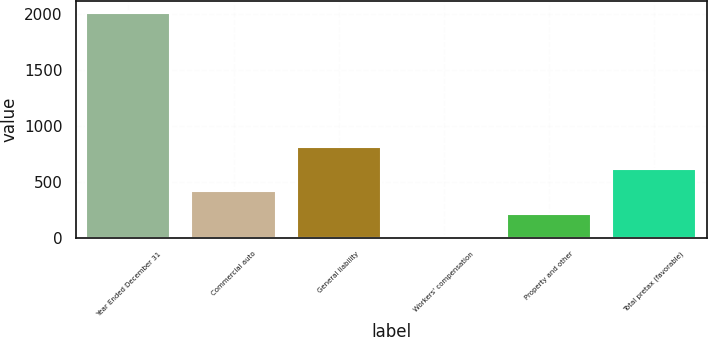Convert chart. <chart><loc_0><loc_0><loc_500><loc_500><bar_chart><fcel>Year Ended December 31<fcel>Commercial auto<fcel>General liability<fcel>Workers' compensation<fcel>Property and other<fcel>Total pretax (favorable)<nl><fcel>2012<fcel>414.4<fcel>813.8<fcel>15<fcel>214.7<fcel>614.1<nl></chart> 